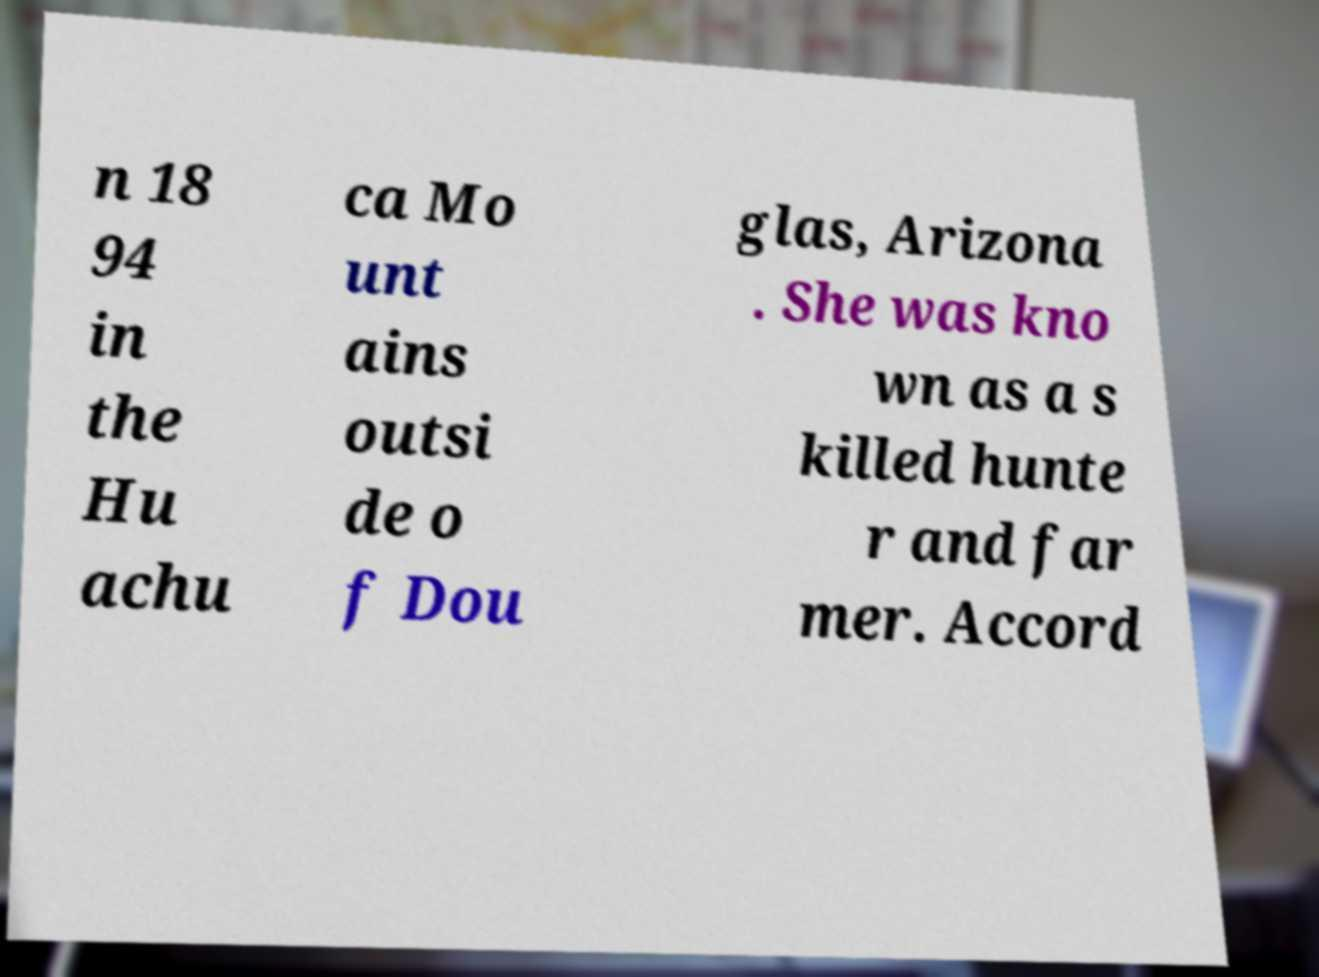Can you accurately transcribe the text from the provided image for me? n 18 94 in the Hu achu ca Mo unt ains outsi de o f Dou glas, Arizona . She was kno wn as a s killed hunte r and far mer. Accord 